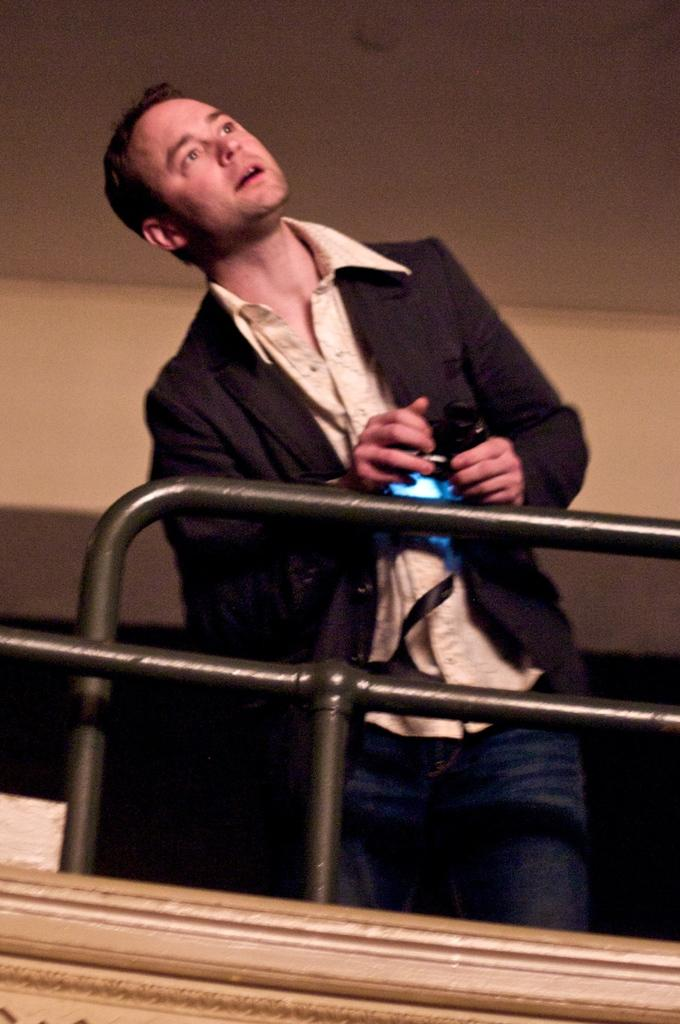What is the main subject of the image? There is a person in the image. What is the person wearing? The person is wearing a black jacket and shirt. What is the person holding in their hands? The person is holding a camera in their hands. Where is the person standing in relation to the railing? The person is standing near the railing. What can be seen in the background of the image? There is a wall in the background of the image. What type of cloth is being used to hold the grandfather in the image? There is no grandfather or cloth present in the image; it features a person holding a camera near a railing with a wall in the background. 